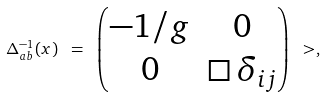Convert formula to latex. <formula><loc_0><loc_0><loc_500><loc_500>\Delta _ { a b } ^ { - 1 } ( x ) \ = \ \begin{pmatrix} - 1 / g & 0 \\ 0 & \Box \, \delta _ { i j } \end{pmatrix} \ > ,</formula> 